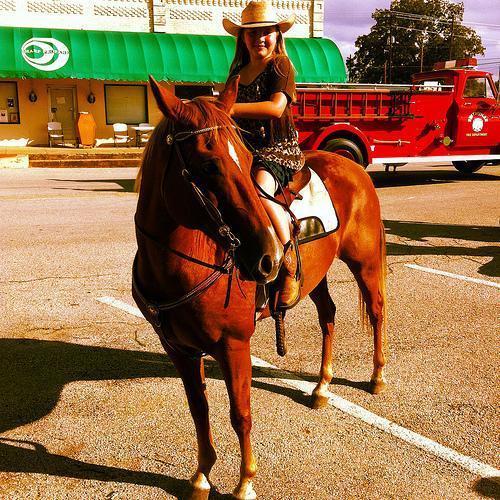How many trucks are there?
Give a very brief answer. 1. How many living organisms are in the picture?
Give a very brief answer. 2. 